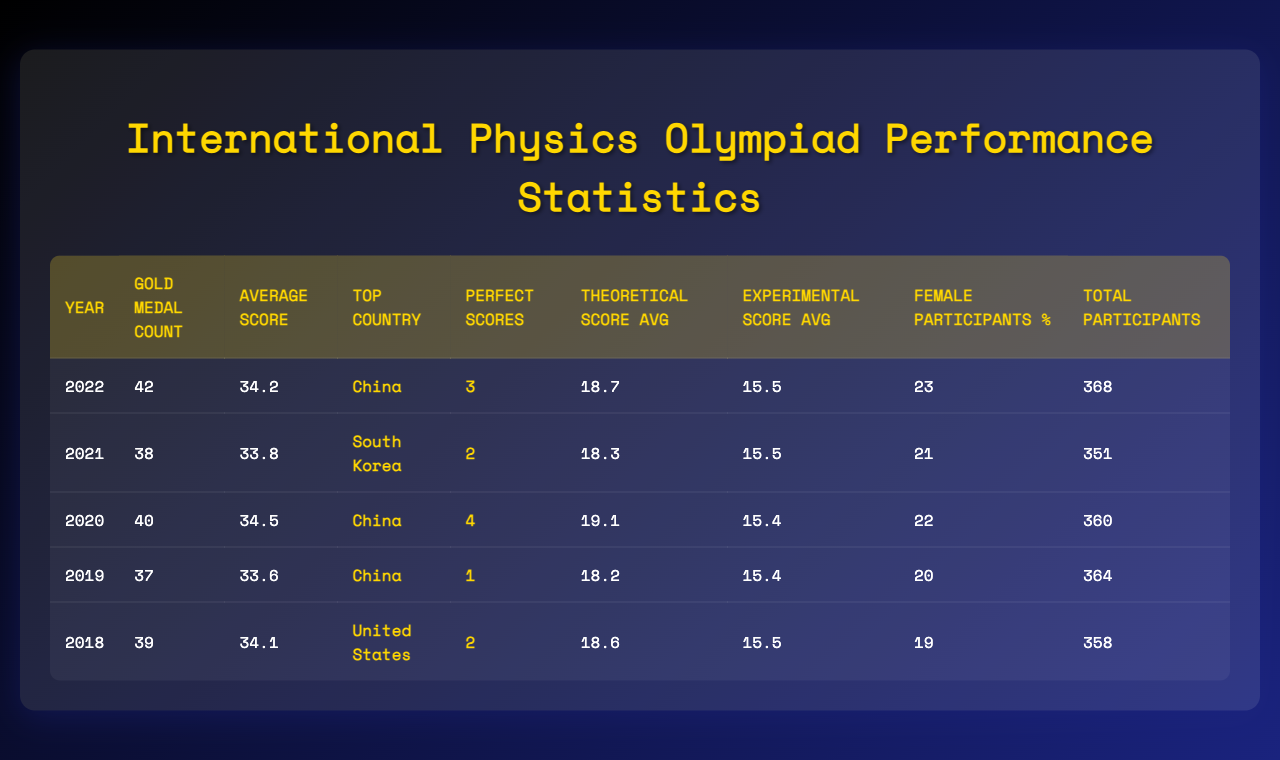What is the average score in 2020? The average score in 2020 is given directly in the table, which shows a score of 34.5 for that year.
Answer: 34.5 Which country had the highest number of gold medals in 2022? According to the table, the top country in 2022 with 42 gold medals is China.
Answer: China How many perfect scores were recorded in 2019? The table indicates that there was 1 perfect score recorded in 2019.
Answer: 1 What was the total number of participants in 2021? The total number of participants for 2021 is explicitly stated in the table as 351.
Answer: 351 In which year did the female participant percentage exceed 22%? By checking the data for each year, it is noted that 23% was achieved in 2022 and 22% in 2020; thus, 2022 is the year when the percentage surpasses 22%.
Answer: 2022 What is the average theoretical score from 2019 to 2022? The theoretical score averages for these years are 18.2 (2019), 18.7 (2020), 18.3 (2021), and 19.1 (2022). Summing them gives 18.2 + 18.7 + 18.3 + 19.1 = 74.3. Dividing by 4 (the number of years) results in an average of 18.575.
Answer: 18.575 Was the average score in 2021 higher than in 2018? The average score for 2021 is 33.8 and for 2018 it's 34.1. Since 33.8 is less than 34.1, the statement is false.
Answer: No Which year had the highest average score? Looking at the average scores in the table, 2020 has the highest average score of 34.5, compared to others.
Answer: 2020 What is the difference in gold medal counts between 2018 and 2021? The gold medal count for 2018 is 39 and for 2021 it is 38. The difference is calculated by subtracting 38 from 39, which equals 1.
Answer: 1 How many total participants were there on average from 2018 to 2022? The total participants for the years are 358 (2018), 364 (2019), 351 (2021), 360 (2020), and 368 (2022). Adding them results in 358 + 364 + 351 + 360 + 368 = 1801. Dividing by 5 gives an average of 360.2.
Answer: 360.2 